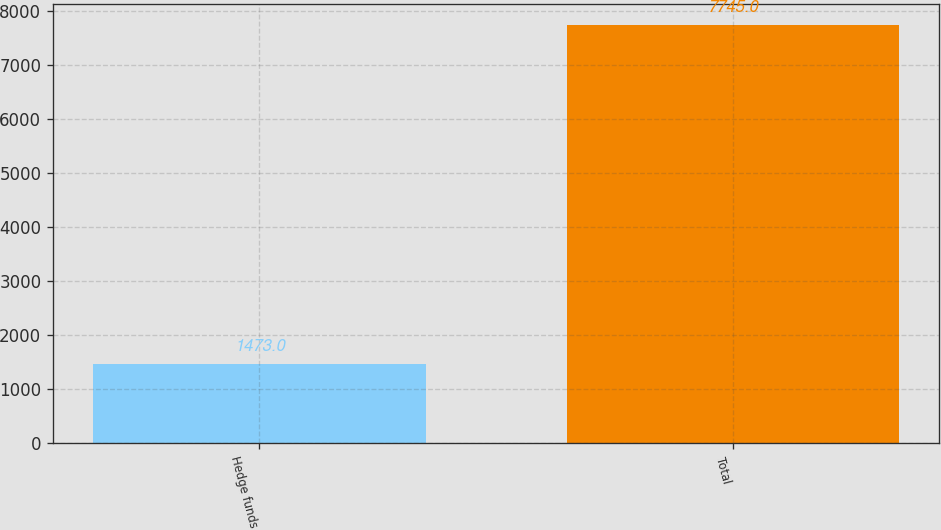Convert chart to OTSL. <chart><loc_0><loc_0><loc_500><loc_500><bar_chart><fcel>Hedge funds<fcel>Total<nl><fcel>1473<fcel>7745<nl></chart> 